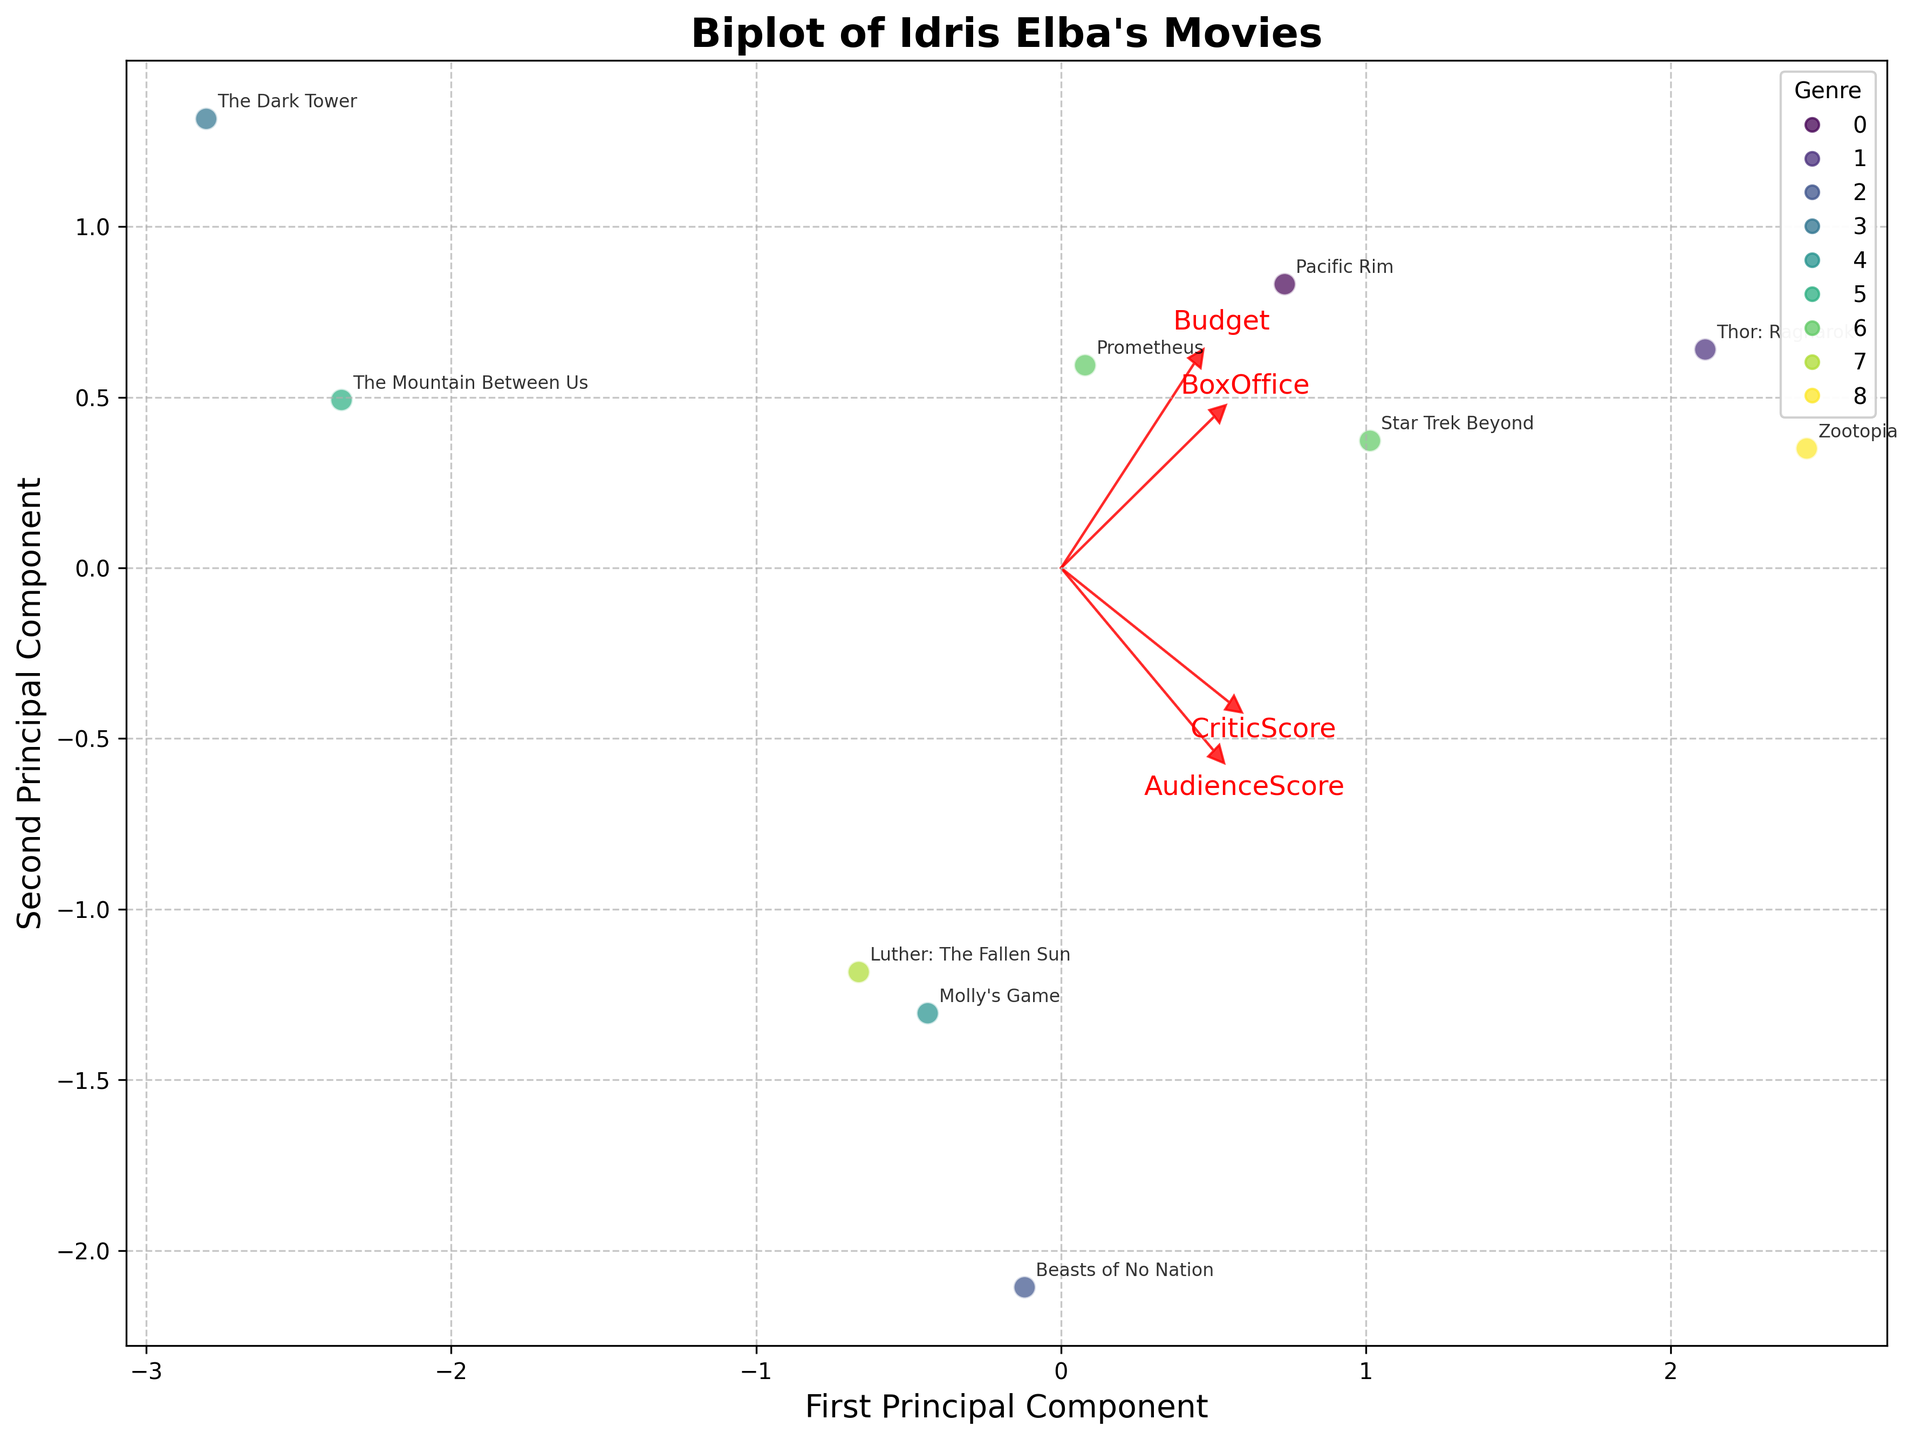How many genres are represented in the biplot? Look at the legend on the upper right of the figure to determine the number of unique colors, each representing a genre.
Answer: 7 Which movie has the highest box office performance? Check the position of each movie along the direction of the "BoxOffice" vector. The movie furthest in the direction of the vector has the highest box office performance.
Answer: Zootopia Which genre shows a high critic score generally? Observe the direction of the "CriticScore" vector and see which genres' data points are closest to it.
Answer: Superhero, Animation Which movie has the smallest budget but high critical reception? Look at the position of the dots relative to the "Budget" and "CriticScore" vectors. Find the movie that is furthest from the "Budget" vector and closest to the "CriticScore" vector.
Answer: Beasts of No Nation Are there any genres that consistently have high audience scores? Observe the proximity of the genres' points to the "AudienceScore" vector.
Answer: Animation Which two movies are closest to each other in the biplot, indicating similar budget and performance characteristics? Identify two dots that are positioned near each other in the plot.
Answer: Molly's Game and The Mountain Between Us Do movies with higher budgets generally have higher box office performance according to the biplot? Check the alignment of movie points along both "Budget" and "BoxOffice" vectors, and see if higher-budget movies generally align with higher "BoxOffice" values.
Answer: Yes Which movie is closest to the origin, indicating average values for all factors? Look for the point closest to the (0,0) position in the biplot.
Answer: Luther: The Fallen Sun 